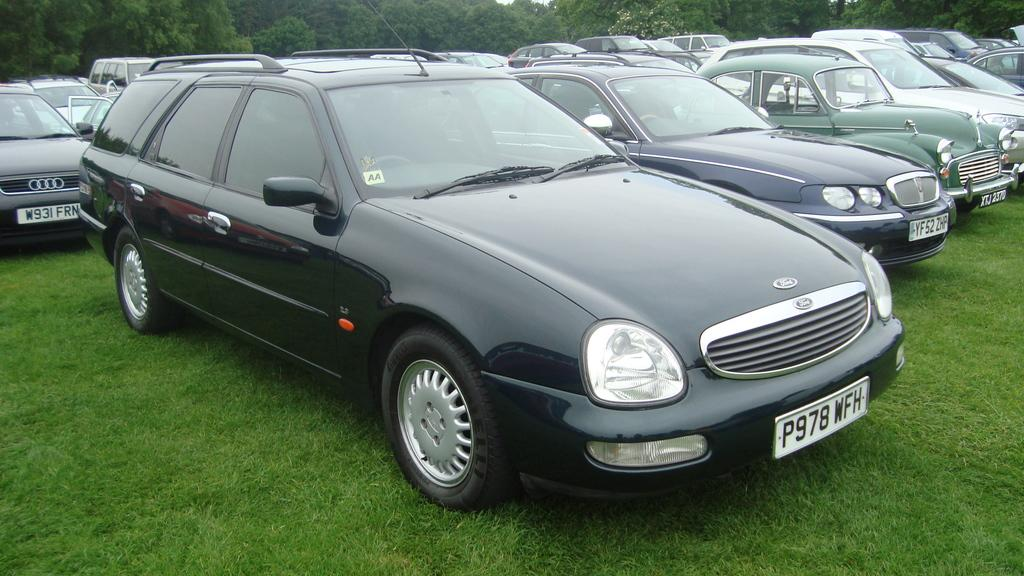What can be seen on the ground in the image? There are many cars parked on the ground in the image. What type of vegetation is present can be seen at the bottom of the image? There is green grass at the bottom of the image. What can be seen in the distance in the image? There are trees in the background of the image. What type of card is being used to generate heat in the image? There is no card or heat generation present in the image. How many arms are visible in the image? There are no arms visible in the image. 